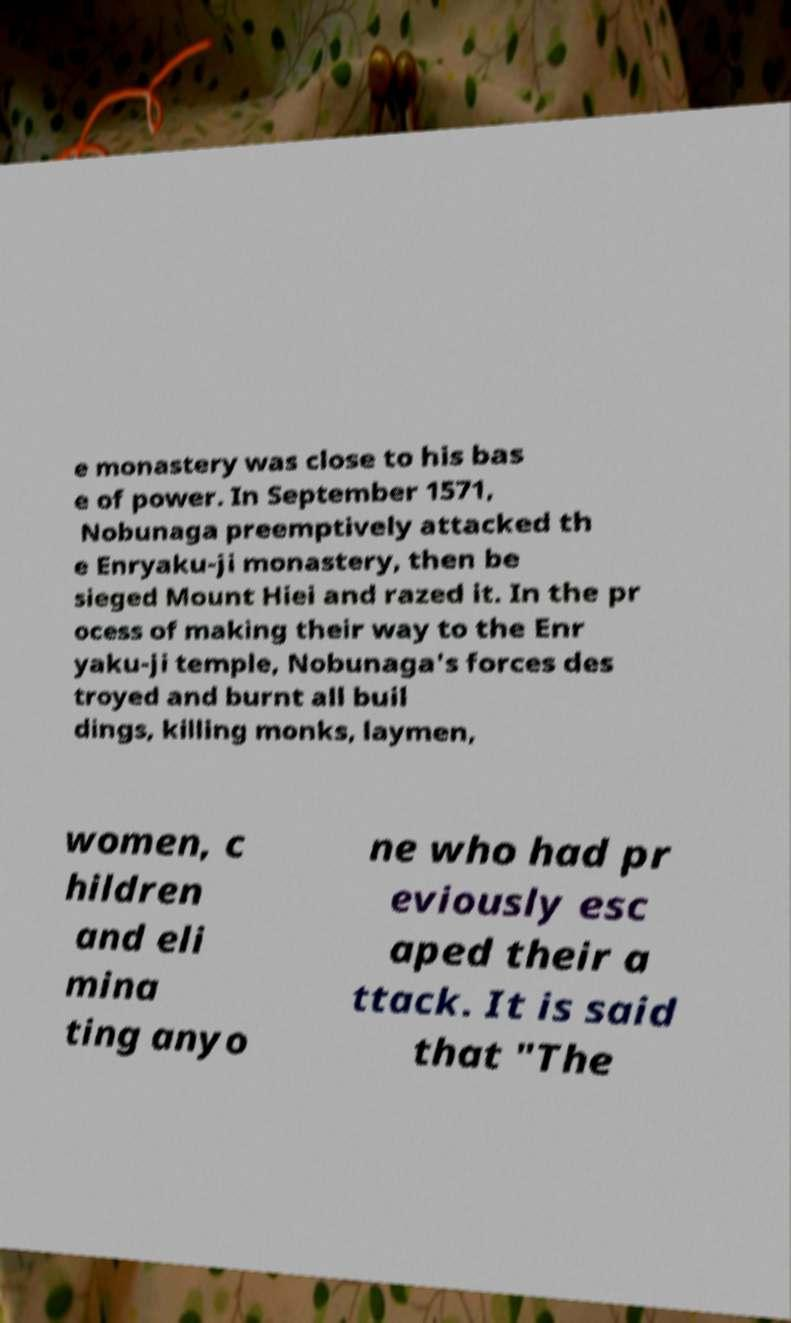Could you extract and type out the text from this image? e monastery was close to his bas e of power. In September 1571, Nobunaga preemptively attacked th e Enryaku-ji monastery, then be sieged Mount Hiei and razed it. In the pr ocess of making their way to the Enr yaku-ji temple, Nobunaga's forces des troyed and burnt all buil dings, killing monks, laymen, women, c hildren and eli mina ting anyo ne who had pr eviously esc aped their a ttack. It is said that "The 